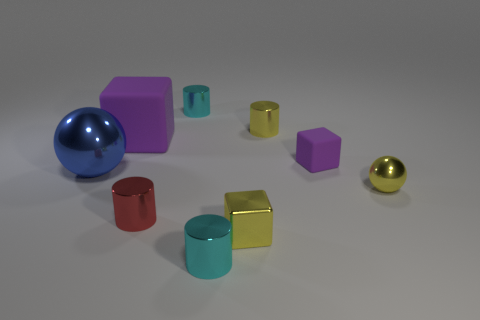How big is the cyan metal object that is in front of the big sphere?
Provide a short and direct response. Small. Do the yellow shiny cube and the red metal object have the same size?
Give a very brief answer. Yes. Are there fewer red metal things behind the large purple matte object than yellow spheres behind the red shiny object?
Ensure brevity in your answer.  Yes. There is a cube that is both to the left of the small purple rubber thing and on the right side of the big purple matte object; what is its size?
Provide a succinct answer. Small. There is a cyan metallic thing on the right side of the small cyan object that is behind the big purple matte thing; is there a small sphere to the left of it?
Make the answer very short. No. Are there any large purple rubber things?
Offer a terse response. Yes. Are there more large blue shiny things that are to the right of the yellow sphere than yellow metal cylinders that are in front of the small purple rubber block?
Keep it short and to the point. No. What is the size of the yellow cube that is made of the same material as the yellow ball?
Offer a terse response. Small. What is the size of the sphere that is to the left of the small cyan cylinder that is left of the tiny cyan thing in front of the small purple rubber cube?
Your answer should be compact. Large. There is a tiny cube in front of the small purple matte object; what is its color?
Offer a very short reply. Yellow. 